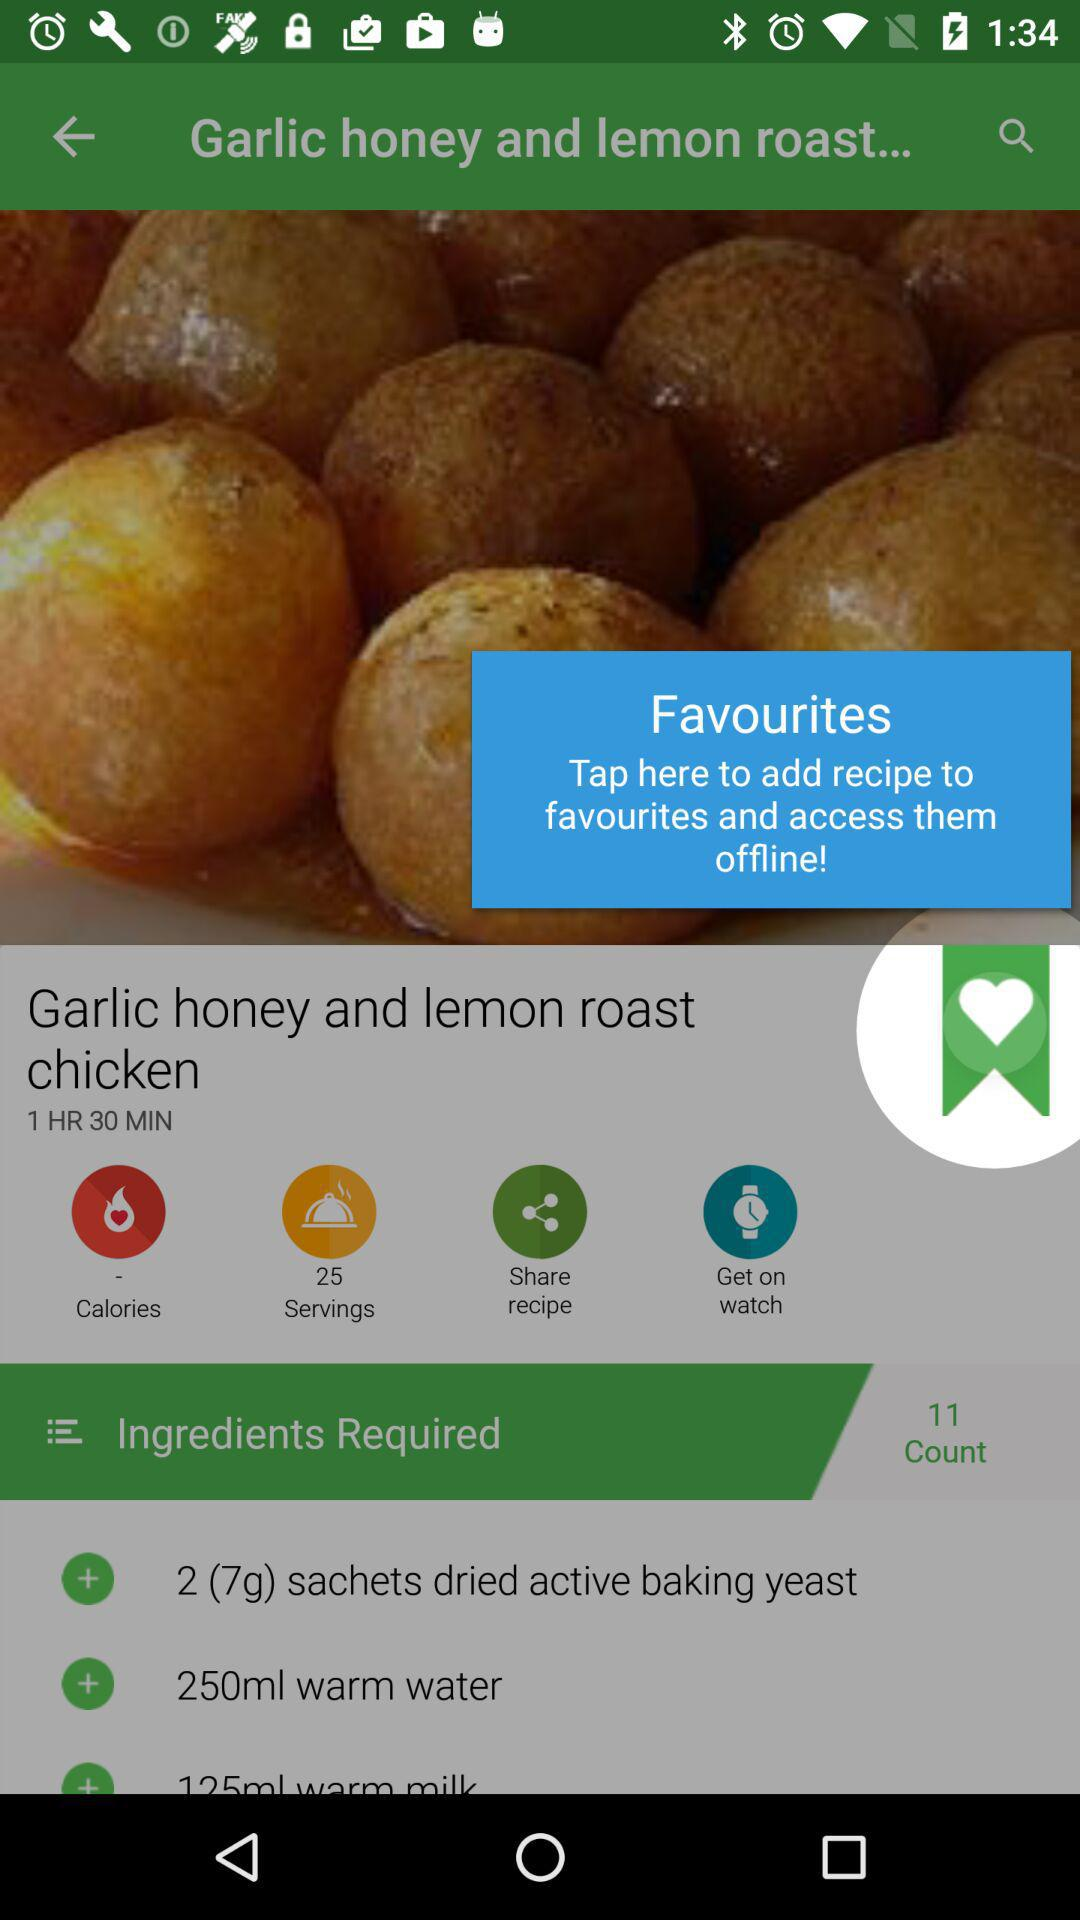How many ingredients are used in the "Garlic honey and lemon roast chicken"? The number of ingredients used in the "Garlic honey and lemon roast chicken" is 11. 